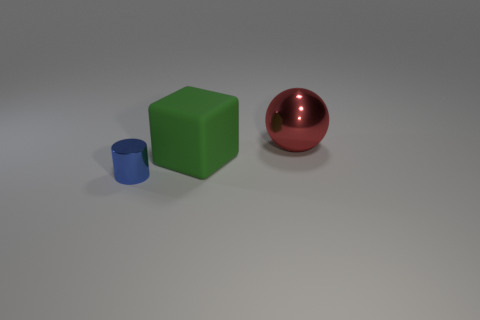Subtract all yellow spheres. Subtract all yellow blocks. How many spheres are left? 1 Add 3 spheres. How many objects exist? 6 Subtract all cylinders. How many objects are left? 2 Add 3 big red metal balls. How many big red metal balls exist? 4 Subtract 0 purple cylinders. How many objects are left? 3 Subtract all big spheres. Subtract all red shiny things. How many objects are left? 1 Add 2 red metal objects. How many red metal objects are left? 3 